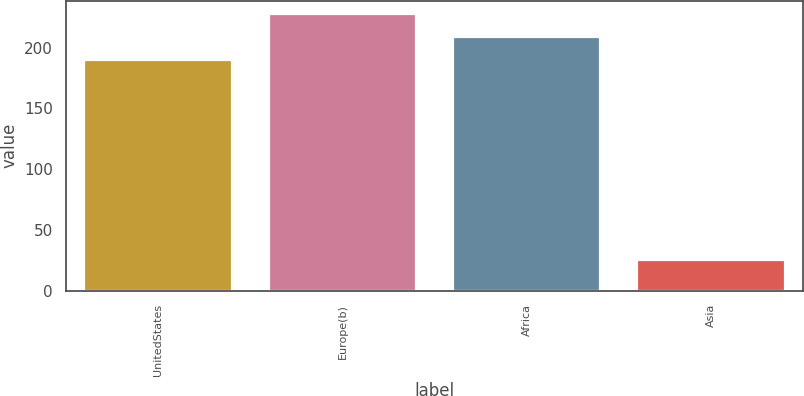<chart> <loc_0><loc_0><loc_500><loc_500><bar_chart><fcel>UnitedStates<fcel>Europe(b)<fcel>Africa<fcel>Asia<nl><fcel>190<fcel>227.4<fcel>208.7<fcel>25<nl></chart> 